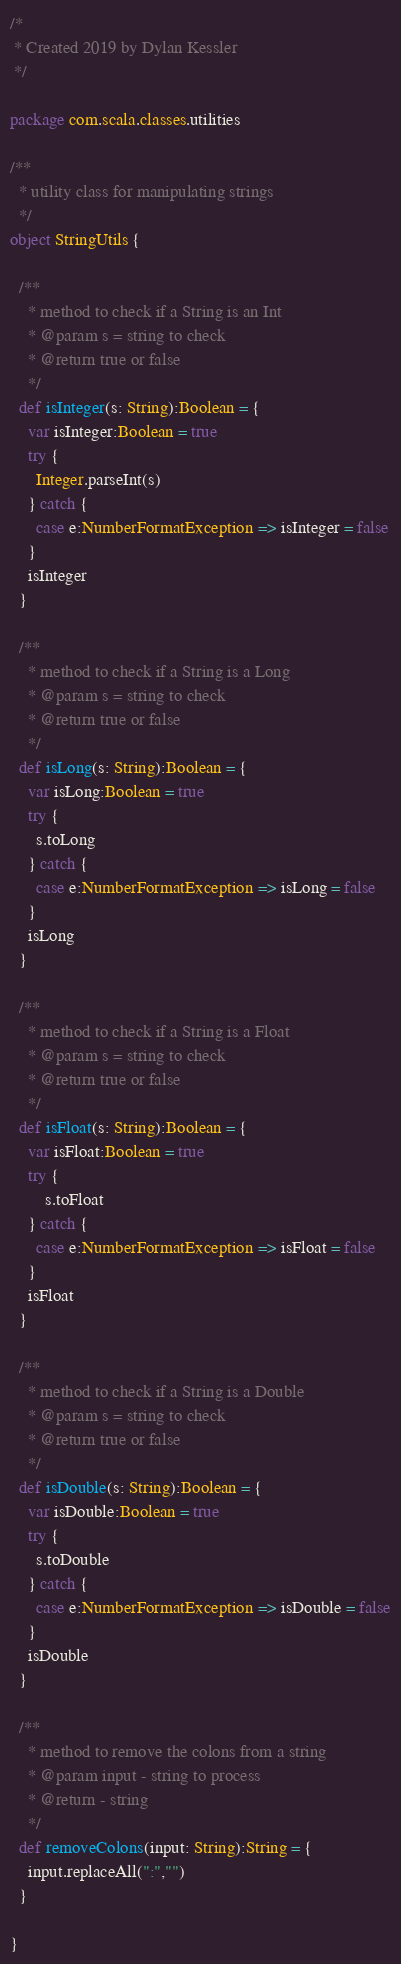<code> <loc_0><loc_0><loc_500><loc_500><_Scala_>/*
 * Created 2019 by Dylan Kessler
 */

package com.scala.classes.utilities

/**
  * utility class for manipulating strings
  */
object StringUtils {

  /**
    * method to check if a String is an Int
    * @param s = string to check
    * @return true or false
    */
  def isInteger(s: String):Boolean = {
    var isInteger:Boolean = true
    try {
      Integer.parseInt(s)
    } catch {
      case e:NumberFormatException => isInteger = false
    }
    isInteger
  }

  /**
    * method to check if a String is a Long
    * @param s = string to check
    * @return true or false
    */
  def isLong(s: String):Boolean = {
    var isLong:Boolean = true
    try {
      s.toLong
    } catch {
      case e:NumberFormatException => isLong = false
    }
    isLong
  }

  /**
    * method to check if a String is a Float
    * @param s = string to check
    * @return true or false
    */
  def isFloat(s: String):Boolean = {
    var isFloat:Boolean = true
    try {
        s.toFloat
    } catch {
      case e:NumberFormatException => isFloat = false
    }
    isFloat
  }

  /**
    * method to check if a String is a Double
    * @param s = string to check
    * @return true or false
    */
  def isDouble(s: String):Boolean = {
    var isDouble:Boolean = true
    try {
      s.toDouble
    } catch {
      case e:NumberFormatException => isDouble = false
    }
    isDouble
  }

  /**
    * method to remove the colons from a string
    * @param input - string to process
    * @return - string
    */
  def removeColons(input: String):String = {
    input.replaceAll(":","")
  }

}
</code> 